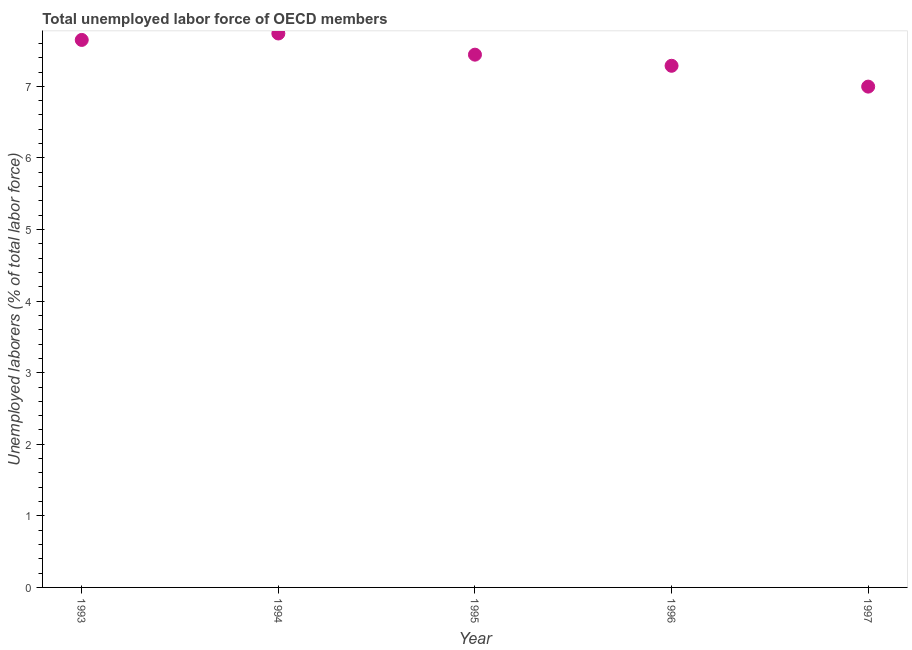What is the total unemployed labour force in 1994?
Give a very brief answer. 7.74. Across all years, what is the maximum total unemployed labour force?
Provide a short and direct response. 7.74. Across all years, what is the minimum total unemployed labour force?
Provide a succinct answer. 7. What is the sum of the total unemployed labour force?
Keep it short and to the point. 37.11. What is the difference between the total unemployed labour force in 1995 and 1997?
Your response must be concise. 0.45. What is the average total unemployed labour force per year?
Provide a short and direct response. 7.42. What is the median total unemployed labour force?
Give a very brief answer. 7.44. Do a majority of the years between 1995 and 1996 (inclusive) have total unemployed labour force greater than 7.4 %?
Provide a short and direct response. No. What is the ratio of the total unemployed labour force in 1993 to that in 1994?
Provide a succinct answer. 0.99. What is the difference between the highest and the second highest total unemployed labour force?
Provide a short and direct response. 0.09. Is the sum of the total unemployed labour force in 1993 and 1996 greater than the maximum total unemployed labour force across all years?
Provide a succinct answer. Yes. What is the difference between the highest and the lowest total unemployed labour force?
Keep it short and to the point. 0.74. In how many years, is the total unemployed labour force greater than the average total unemployed labour force taken over all years?
Your response must be concise. 3. How many dotlines are there?
Your answer should be compact. 1. Does the graph contain grids?
Provide a succinct answer. No. What is the title of the graph?
Offer a very short reply. Total unemployed labor force of OECD members. What is the label or title of the X-axis?
Provide a short and direct response. Year. What is the label or title of the Y-axis?
Make the answer very short. Unemployed laborers (% of total labor force). What is the Unemployed laborers (% of total labor force) in 1993?
Your answer should be very brief. 7.65. What is the Unemployed laborers (% of total labor force) in 1994?
Your answer should be very brief. 7.74. What is the Unemployed laborers (% of total labor force) in 1995?
Make the answer very short. 7.44. What is the Unemployed laborers (% of total labor force) in 1996?
Keep it short and to the point. 7.29. What is the Unemployed laborers (% of total labor force) in 1997?
Make the answer very short. 7. What is the difference between the Unemployed laborers (% of total labor force) in 1993 and 1994?
Offer a terse response. -0.09. What is the difference between the Unemployed laborers (% of total labor force) in 1993 and 1995?
Make the answer very short. 0.21. What is the difference between the Unemployed laborers (% of total labor force) in 1993 and 1996?
Give a very brief answer. 0.36. What is the difference between the Unemployed laborers (% of total labor force) in 1993 and 1997?
Give a very brief answer. 0.65. What is the difference between the Unemployed laborers (% of total labor force) in 1994 and 1995?
Offer a very short reply. 0.3. What is the difference between the Unemployed laborers (% of total labor force) in 1994 and 1996?
Your answer should be compact. 0.45. What is the difference between the Unemployed laborers (% of total labor force) in 1994 and 1997?
Your answer should be compact. 0.74. What is the difference between the Unemployed laborers (% of total labor force) in 1995 and 1996?
Give a very brief answer. 0.16. What is the difference between the Unemployed laborers (% of total labor force) in 1995 and 1997?
Provide a short and direct response. 0.45. What is the difference between the Unemployed laborers (% of total labor force) in 1996 and 1997?
Your answer should be very brief. 0.29. What is the ratio of the Unemployed laborers (% of total labor force) in 1993 to that in 1994?
Your response must be concise. 0.99. What is the ratio of the Unemployed laborers (% of total labor force) in 1993 to that in 1995?
Keep it short and to the point. 1.03. What is the ratio of the Unemployed laborers (% of total labor force) in 1993 to that in 1996?
Make the answer very short. 1.05. What is the ratio of the Unemployed laborers (% of total labor force) in 1993 to that in 1997?
Provide a short and direct response. 1.09. What is the ratio of the Unemployed laborers (% of total labor force) in 1994 to that in 1996?
Your answer should be compact. 1.06. What is the ratio of the Unemployed laborers (% of total labor force) in 1994 to that in 1997?
Provide a short and direct response. 1.11. What is the ratio of the Unemployed laborers (% of total labor force) in 1995 to that in 1997?
Offer a terse response. 1.06. What is the ratio of the Unemployed laborers (% of total labor force) in 1996 to that in 1997?
Your response must be concise. 1.04. 